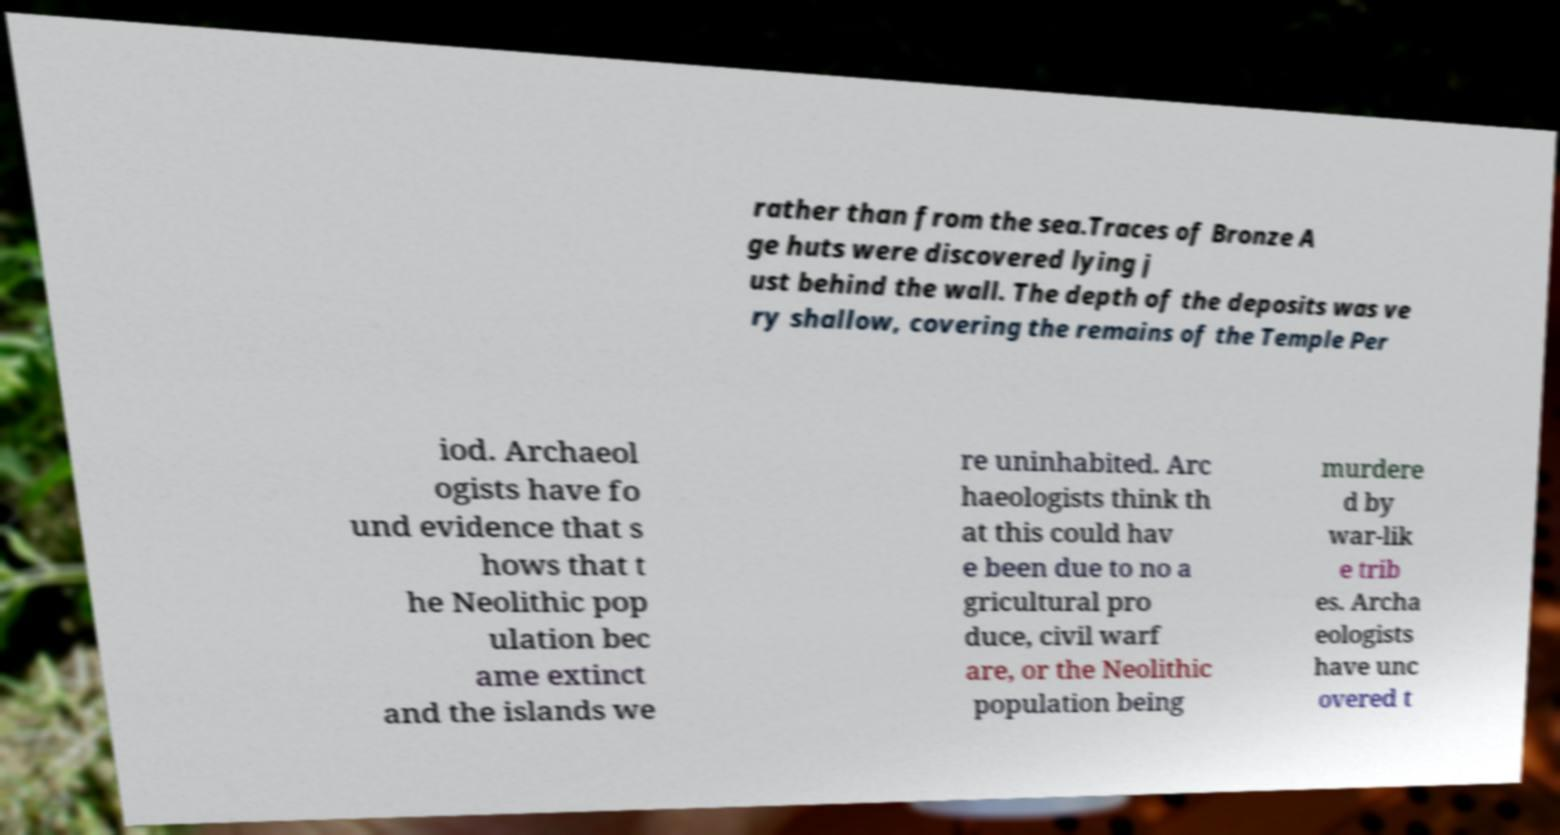Please read and relay the text visible in this image. What does it say? rather than from the sea.Traces of Bronze A ge huts were discovered lying j ust behind the wall. The depth of the deposits was ve ry shallow, covering the remains of the Temple Per iod. Archaeol ogists have fo und evidence that s hows that t he Neolithic pop ulation bec ame extinct and the islands we re uninhabited. Arc haeologists think th at this could hav e been due to no a gricultural pro duce, civil warf are, or the Neolithic population being murdere d by war-lik e trib es. Archa eologists have unc overed t 